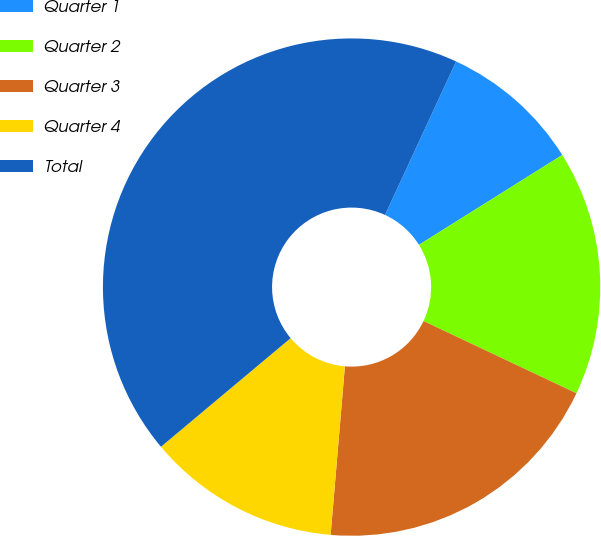<chart> <loc_0><loc_0><loc_500><loc_500><pie_chart><fcel>Quarter 1<fcel>Quarter 2<fcel>Quarter 3<fcel>Quarter 4<fcel>Total<nl><fcel>9.18%<fcel>15.94%<fcel>19.32%<fcel>12.56%<fcel>43.0%<nl></chart> 